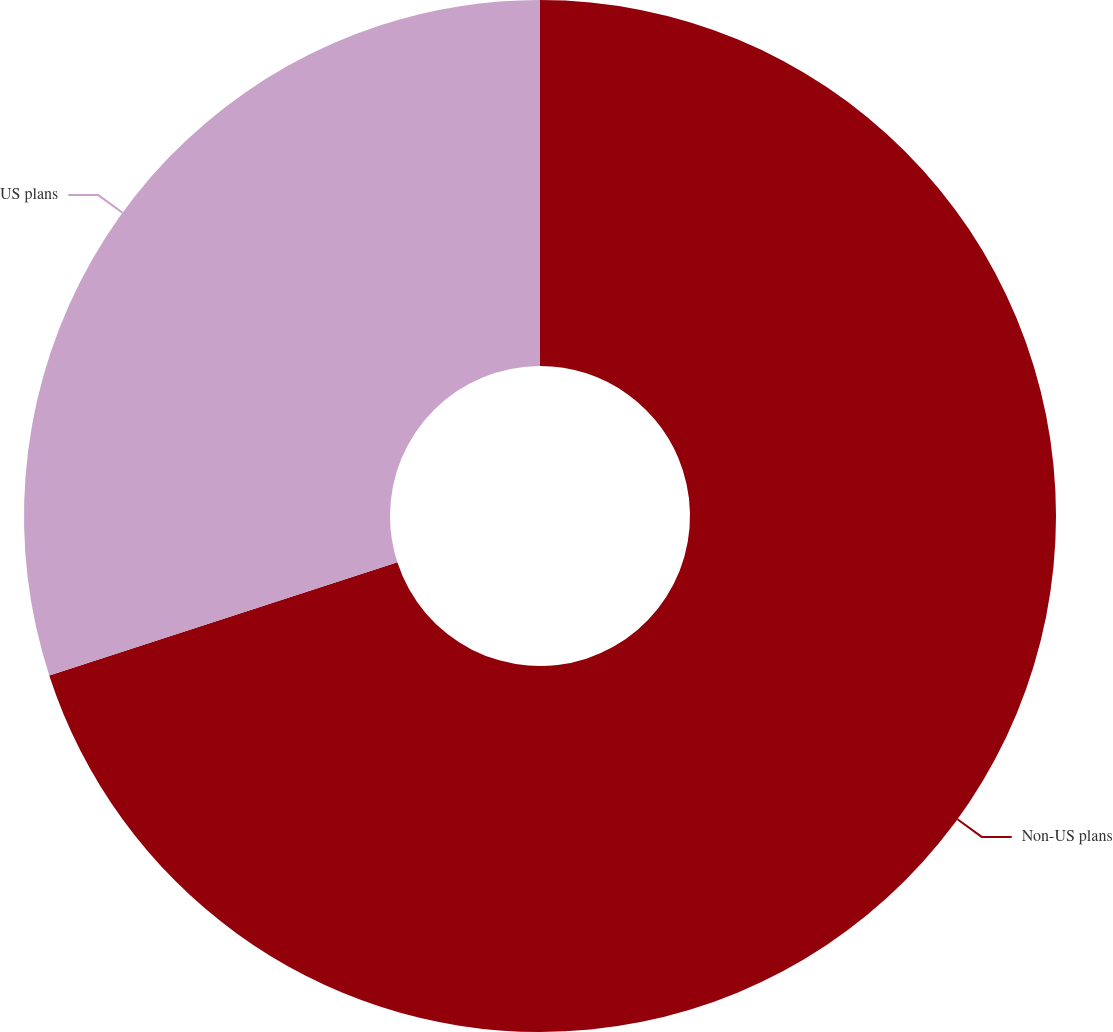Convert chart. <chart><loc_0><loc_0><loc_500><loc_500><pie_chart><fcel>Non-US plans<fcel>US plans<nl><fcel>70.0%<fcel>30.0%<nl></chart> 